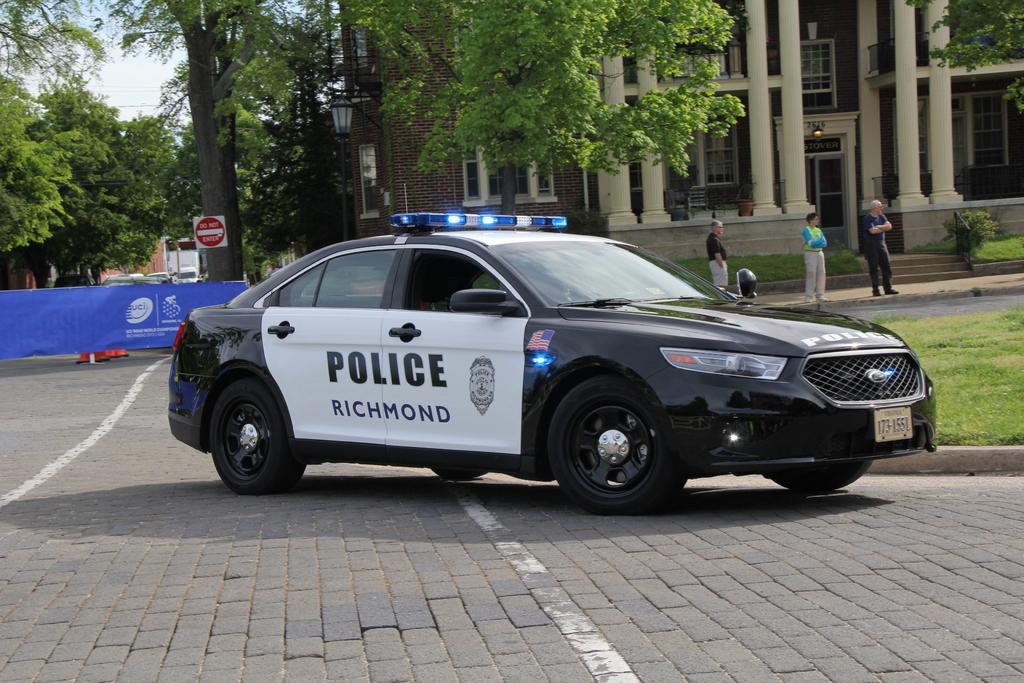Could you give a brief overview of what you see in this image? In this image there is a car on a pavement, in the background there are people standing and there is a building trees and a board, on that board there are logos. 